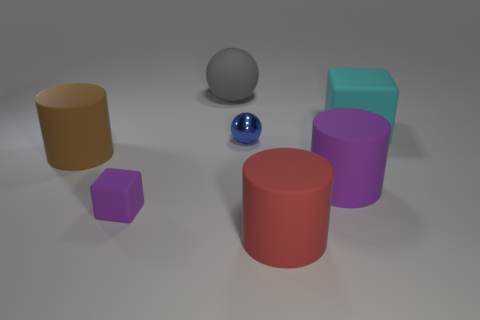Are there any other things that have the same material as the small sphere?
Offer a very short reply. No. Does the block that is on the left side of the big cyan matte block have the same color as the cylinder that is on the right side of the large red cylinder?
Ensure brevity in your answer.  Yes. The large brown thing is what shape?
Your answer should be very brief. Cylinder. Is the number of big things that are on the left side of the metallic thing greater than the number of small purple cubes?
Offer a terse response. Yes. There is a tiny object behind the big brown rubber cylinder; what shape is it?
Keep it short and to the point. Sphere. How many other objects are the same shape as the large gray thing?
Offer a terse response. 1. Are the big cylinder that is left of the big sphere and the blue thing made of the same material?
Your answer should be very brief. No. Is the number of big matte cubes that are in front of the red rubber cylinder the same as the number of matte objects that are right of the rubber ball?
Your answer should be very brief. No. How big is the rubber cylinder that is on the left side of the gray rubber object?
Your response must be concise. Large. Is there a small purple block that has the same material as the big gray object?
Offer a terse response. Yes. 